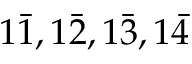<formula> <loc_0><loc_0><loc_500><loc_500>1 { \bar { 1 } } , 1 { \bar { 2 } } , 1 { \bar { 3 } } , 1 { \bar { 4 } }</formula> 